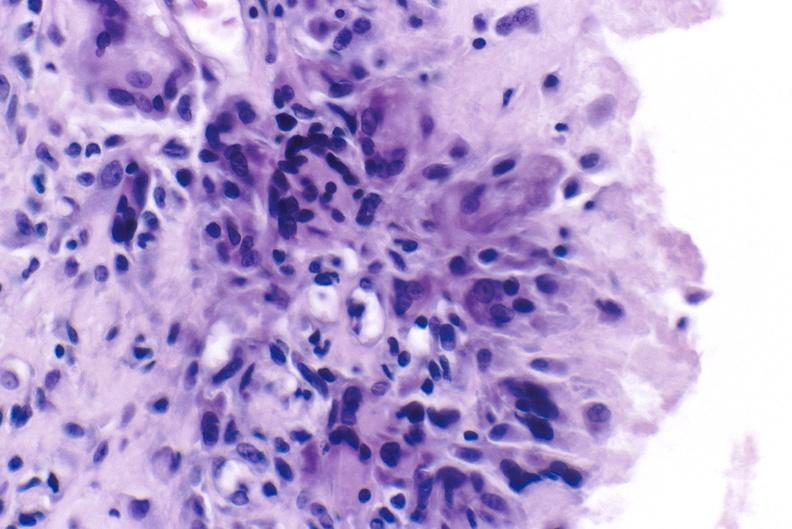what is present?
Answer the question using a single word or phrase. Joints 